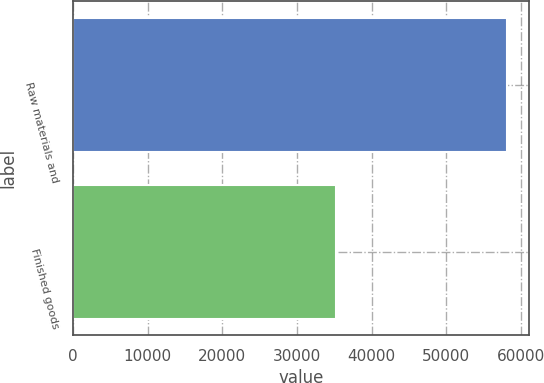Convert chart to OTSL. <chart><loc_0><loc_0><loc_500><loc_500><bar_chart><fcel>Raw materials and<fcel>Finished goods<nl><fcel>58226<fcel>35251<nl></chart> 